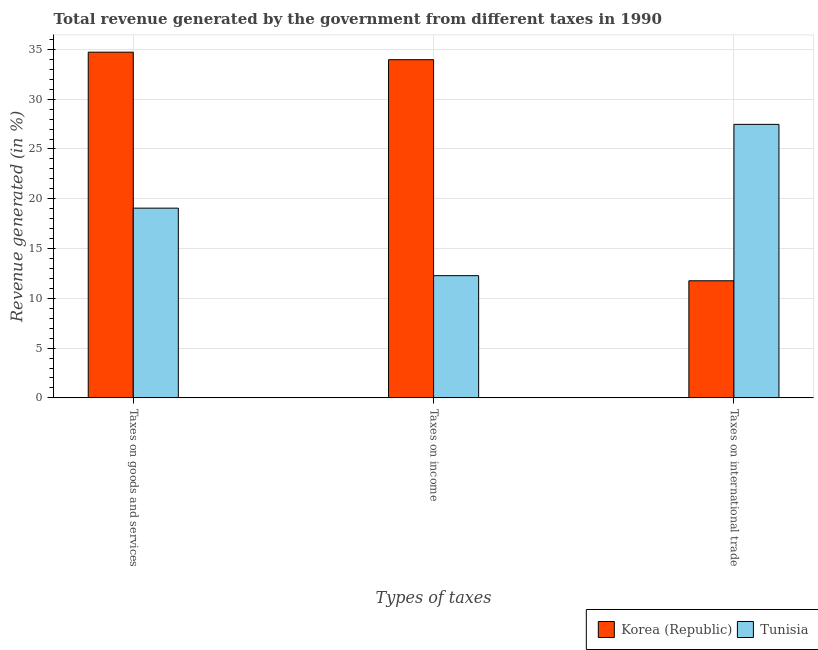How many groups of bars are there?
Provide a succinct answer. 3. Are the number of bars per tick equal to the number of legend labels?
Offer a terse response. Yes. Are the number of bars on each tick of the X-axis equal?
Offer a terse response. Yes. What is the label of the 1st group of bars from the left?
Offer a very short reply. Taxes on goods and services. What is the percentage of revenue generated by taxes on income in Tunisia?
Your answer should be very brief. 12.27. Across all countries, what is the maximum percentage of revenue generated by taxes on income?
Offer a very short reply. 33.97. Across all countries, what is the minimum percentage of revenue generated by taxes on goods and services?
Offer a very short reply. 19.06. In which country was the percentage of revenue generated by taxes on income minimum?
Give a very brief answer. Tunisia. What is the total percentage of revenue generated by taxes on income in the graph?
Your answer should be very brief. 46.24. What is the difference between the percentage of revenue generated by taxes on income in Korea (Republic) and that in Tunisia?
Provide a succinct answer. 21.69. What is the difference between the percentage of revenue generated by tax on international trade in Korea (Republic) and the percentage of revenue generated by taxes on goods and services in Tunisia?
Provide a short and direct response. -7.3. What is the average percentage of revenue generated by tax on international trade per country?
Your answer should be compact. 19.62. What is the difference between the percentage of revenue generated by taxes on income and percentage of revenue generated by tax on international trade in Tunisia?
Provide a succinct answer. -15.2. In how many countries, is the percentage of revenue generated by tax on international trade greater than 25 %?
Give a very brief answer. 1. What is the ratio of the percentage of revenue generated by taxes on income in Korea (Republic) to that in Tunisia?
Make the answer very short. 2.77. Is the percentage of revenue generated by tax on international trade in Tunisia less than that in Korea (Republic)?
Provide a succinct answer. No. Is the difference between the percentage of revenue generated by tax on international trade in Tunisia and Korea (Republic) greater than the difference between the percentage of revenue generated by taxes on income in Tunisia and Korea (Republic)?
Offer a very short reply. Yes. What is the difference between the highest and the second highest percentage of revenue generated by taxes on goods and services?
Offer a very short reply. 15.67. What is the difference between the highest and the lowest percentage of revenue generated by taxes on income?
Give a very brief answer. 21.69. In how many countries, is the percentage of revenue generated by tax on international trade greater than the average percentage of revenue generated by tax on international trade taken over all countries?
Ensure brevity in your answer.  1. What does the 2nd bar from the left in Taxes on income represents?
Your response must be concise. Tunisia. What does the 1st bar from the right in Taxes on international trade represents?
Offer a very short reply. Tunisia. How many countries are there in the graph?
Your answer should be very brief. 2. Are the values on the major ticks of Y-axis written in scientific E-notation?
Provide a succinct answer. No. Does the graph contain any zero values?
Your answer should be compact. No. Does the graph contain grids?
Make the answer very short. Yes. How many legend labels are there?
Your answer should be compact. 2. How are the legend labels stacked?
Offer a very short reply. Horizontal. What is the title of the graph?
Keep it short and to the point. Total revenue generated by the government from different taxes in 1990. Does "Iraq" appear as one of the legend labels in the graph?
Make the answer very short. No. What is the label or title of the X-axis?
Keep it short and to the point. Types of taxes. What is the label or title of the Y-axis?
Give a very brief answer. Revenue generated (in %). What is the Revenue generated (in %) of Korea (Republic) in Taxes on goods and services?
Your answer should be very brief. 34.72. What is the Revenue generated (in %) in Tunisia in Taxes on goods and services?
Your answer should be compact. 19.06. What is the Revenue generated (in %) of Korea (Republic) in Taxes on income?
Your answer should be compact. 33.97. What is the Revenue generated (in %) of Tunisia in Taxes on income?
Give a very brief answer. 12.27. What is the Revenue generated (in %) of Korea (Republic) in Taxes on international trade?
Provide a short and direct response. 11.76. What is the Revenue generated (in %) of Tunisia in Taxes on international trade?
Your answer should be very brief. 27.47. Across all Types of taxes, what is the maximum Revenue generated (in %) in Korea (Republic)?
Give a very brief answer. 34.72. Across all Types of taxes, what is the maximum Revenue generated (in %) of Tunisia?
Provide a short and direct response. 27.47. Across all Types of taxes, what is the minimum Revenue generated (in %) of Korea (Republic)?
Ensure brevity in your answer.  11.76. Across all Types of taxes, what is the minimum Revenue generated (in %) in Tunisia?
Provide a succinct answer. 12.27. What is the total Revenue generated (in %) in Korea (Republic) in the graph?
Keep it short and to the point. 80.45. What is the total Revenue generated (in %) in Tunisia in the graph?
Offer a terse response. 58.8. What is the difference between the Revenue generated (in %) in Korea (Republic) in Taxes on goods and services and that in Taxes on income?
Your response must be concise. 0.76. What is the difference between the Revenue generated (in %) in Tunisia in Taxes on goods and services and that in Taxes on income?
Provide a short and direct response. 6.78. What is the difference between the Revenue generated (in %) in Korea (Republic) in Taxes on goods and services and that in Taxes on international trade?
Make the answer very short. 22.96. What is the difference between the Revenue generated (in %) in Tunisia in Taxes on goods and services and that in Taxes on international trade?
Offer a very short reply. -8.42. What is the difference between the Revenue generated (in %) in Korea (Republic) in Taxes on income and that in Taxes on international trade?
Your answer should be very brief. 22.21. What is the difference between the Revenue generated (in %) in Tunisia in Taxes on income and that in Taxes on international trade?
Provide a short and direct response. -15.2. What is the difference between the Revenue generated (in %) of Korea (Republic) in Taxes on goods and services and the Revenue generated (in %) of Tunisia in Taxes on income?
Give a very brief answer. 22.45. What is the difference between the Revenue generated (in %) of Korea (Republic) in Taxes on goods and services and the Revenue generated (in %) of Tunisia in Taxes on international trade?
Your response must be concise. 7.25. What is the difference between the Revenue generated (in %) in Korea (Republic) in Taxes on income and the Revenue generated (in %) in Tunisia in Taxes on international trade?
Your answer should be compact. 6.5. What is the average Revenue generated (in %) in Korea (Republic) per Types of taxes?
Offer a terse response. 26.82. What is the average Revenue generated (in %) of Tunisia per Types of taxes?
Provide a succinct answer. 19.6. What is the difference between the Revenue generated (in %) of Korea (Republic) and Revenue generated (in %) of Tunisia in Taxes on goods and services?
Offer a very short reply. 15.67. What is the difference between the Revenue generated (in %) in Korea (Republic) and Revenue generated (in %) in Tunisia in Taxes on income?
Give a very brief answer. 21.69. What is the difference between the Revenue generated (in %) in Korea (Republic) and Revenue generated (in %) in Tunisia in Taxes on international trade?
Ensure brevity in your answer.  -15.71. What is the ratio of the Revenue generated (in %) in Korea (Republic) in Taxes on goods and services to that in Taxes on income?
Offer a terse response. 1.02. What is the ratio of the Revenue generated (in %) in Tunisia in Taxes on goods and services to that in Taxes on income?
Make the answer very short. 1.55. What is the ratio of the Revenue generated (in %) in Korea (Republic) in Taxes on goods and services to that in Taxes on international trade?
Keep it short and to the point. 2.95. What is the ratio of the Revenue generated (in %) in Tunisia in Taxes on goods and services to that in Taxes on international trade?
Provide a succinct answer. 0.69. What is the ratio of the Revenue generated (in %) in Korea (Republic) in Taxes on income to that in Taxes on international trade?
Provide a succinct answer. 2.89. What is the ratio of the Revenue generated (in %) in Tunisia in Taxes on income to that in Taxes on international trade?
Offer a very short reply. 0.45. What is the difference between the highest and the second highest Revenue generated (in %) in Korea (Republic)?
Your response must be concise. 0.76. What is the difference between the highest and the second highest Revenue generated (in %) of Tunisia?
Your answer should be compact. 8.42. What is the difference between the highest and the lowest Revenue generated (in %) of Korea (Republic)?
Your answer should be very brief. 22.96. What is the difference between the highest and the lowest Revenue generated (in %) of Tunisia?
Provide a short and direct response. 15.2. 